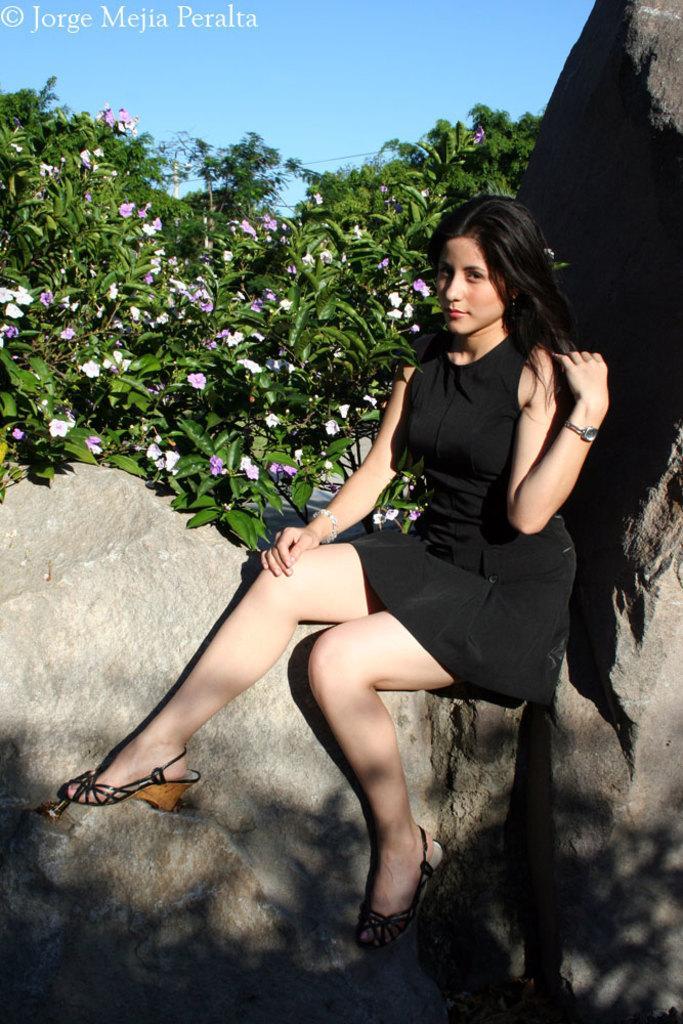Could you give a brief overview of what you see in this image? In this image there is a lady sitting on rock, in the background there are trees. 